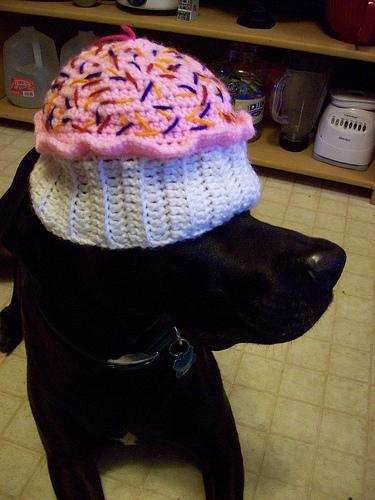Question: why is the dog wearing a hat?
Choices:
A. It's sunny.
B. It's raining.
C. It's cold.
D. It's snowing.
Answer with the letter. Answer: C Question: how many people are in the picture?
Choices:
A. 5.
B. None.
C. 3.
D. 7.
Answer with the letter. Answer: B Question: what design is on the top of the hat?
Choices:
A. Glitter.
B. Sprinkles.
C. Dots.
D. Specks.
Answer with the letter. Answer: B Question: what does the dog have on its head?
Choices:
A. Cap.
B. Baseball hat.
C. A hat.
D. Clothing.
Answer with the letter. Answer: C Question: who put the hat on the dog?
Choices:
A. The boy..
B. The girl.
C. The vet.
D. The owner.
Answer with the letter. Answer: D 